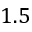Convert formula to latex. <formula><loc_0><loc_0><loc_500><loc_500>1 . 5</formula> 